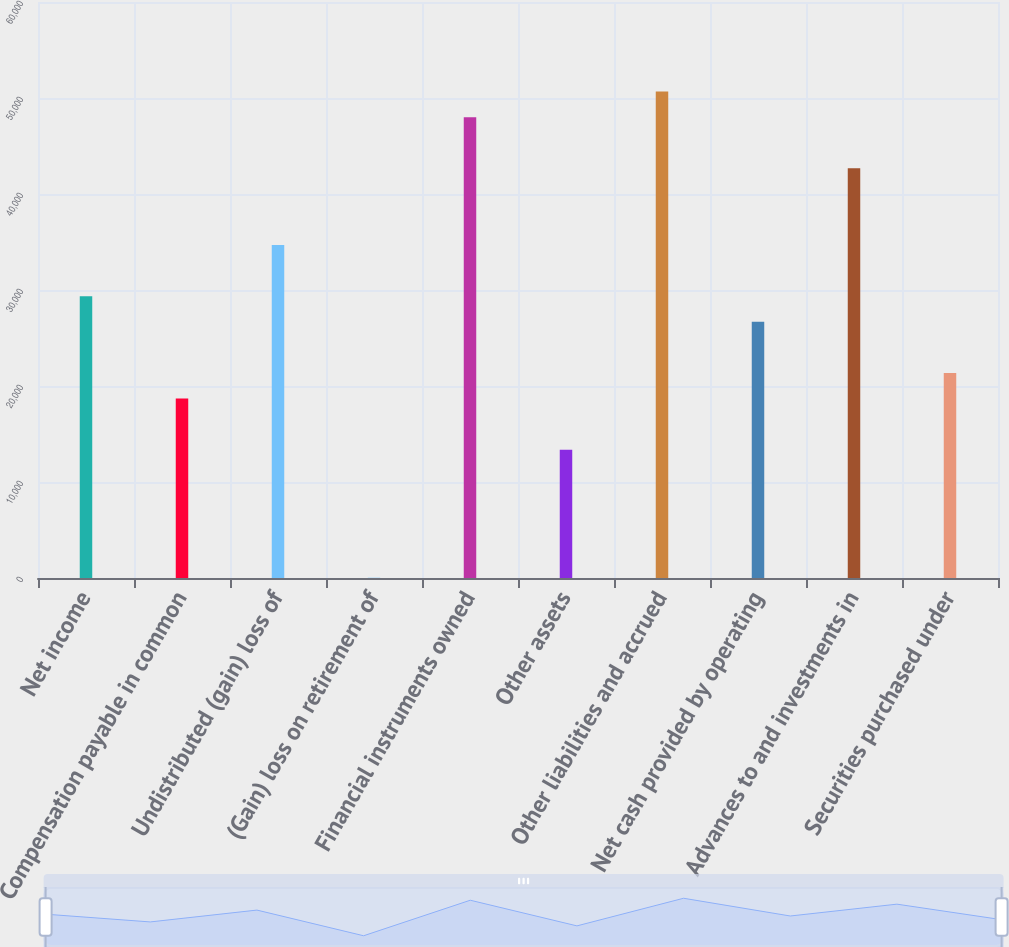<chart> <loc_0><loc_0><loc_500><loc_500><bar_chart><fcel>Net income<fcel>Compensation payable in common<fcel>Undistributed (gain) loss of<fcel>(Gain) loss on retirement of<fcel>Financial instruments owned<fcel>Other assets<fcel>Other liabilities and accrued<fcel>Net cash provided by operating<fcel>Advances to and investments in<fcel>Securities purchased under<nl><fcel>29348.6<fcel>18686.2<fcel>34679.8<fcel>27<fcel>48007.8<fcel>13355<fcel>50673.4<fcel>26683<fcel>42676.6<fcel>21351.8<nl></chart> 